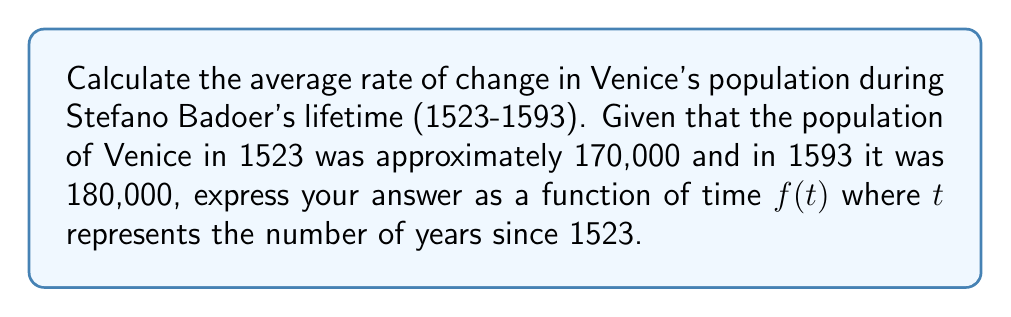Solve this math problem. To calculate the average rate of change in Venice's population during Stefano Badoer's lifetime, we need to follow these steps:

1. Identify the given information:
   - Initial year: 1523
   - Final year: 1593
   - Initial population: 170,000
   - Final population: 180,000

2. Calculate the total change in population:
   $\Delta y = 180,000 - 170,000 = 10,000$

3. Calculate the total time interval:
   $\Delta t = 1593 - 1523 = 70$ years

4. Calculate the average rate of change using the formula:
   $$\text{Average rate of change} = \frac{\Delta y}{\Delta t} = \frac{10,000}{70} \approx 142.86$$

5. Express the population as a function of time $f(t)$, where $t$ represents the number of years since 1523:
   $$f(t) = 170,000 + 142.86t$$

   This linear function represents the estimated population at any given year during Badoer's lifetime, assuming a constant rate of change.

6. Verify the function:
   At $t = 0$ (1523): $f(0) = 170,000 + 142.86(0) = 170,000$
   At $t = 70$ (1593): $f(70) \approx 170,000 + 142.86(70) \approx 180,000$

Thus, the function $f(t) = 170,000 + 142.86t$ accurately represents the population change during Stefano Badoer's lifetime.
Answer: $f(t) = 170,000 + 142.86t$ 